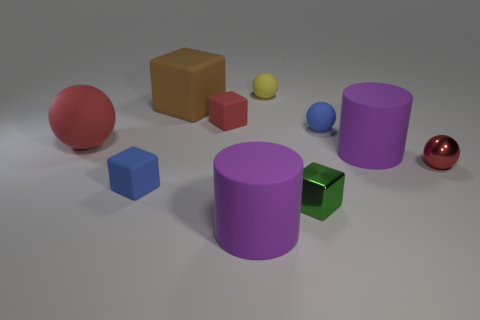Subtract 1 spheres. How many spheres are left? 3 Subtract all blocks. How many objects are left? 6 Subtract 0 brown spheres. How many objects are left? 10 Subtract all red rubber blocks. Subtract all balls. How many objects are left? 5 Add 9 small blue spheres. How many small blue spheres are left? 10 Add 3 yellow matte balls. How many yellow matte balls exist? 4 